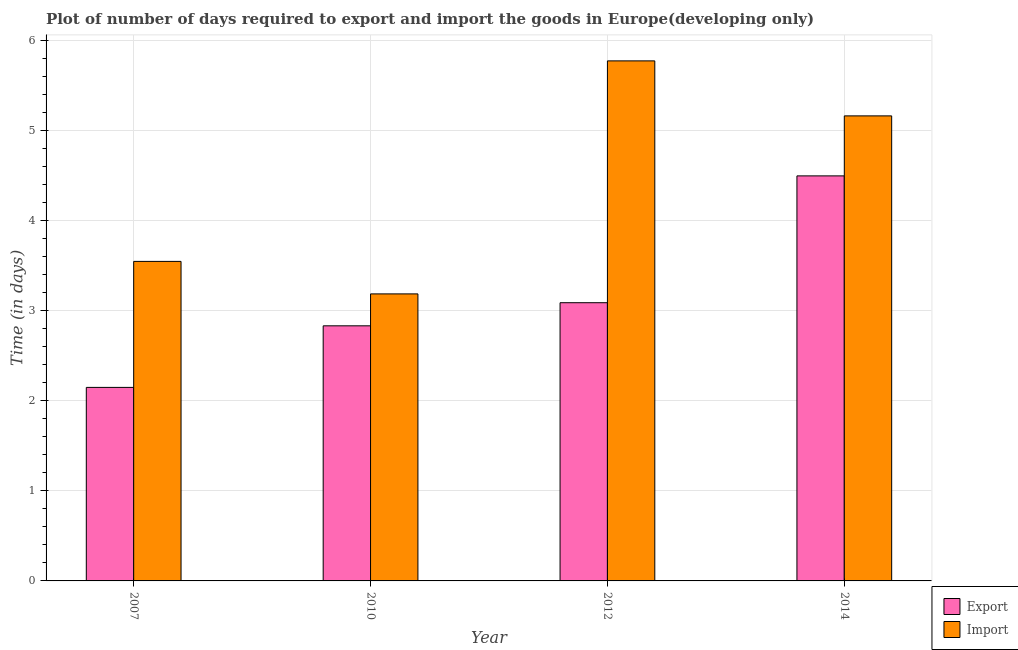How many different coloured bars are there?
Make the answer very short. 2. How many groups of bars are there?
Provide a short and direct response. 4. Are the number of bars per tick equal to the number of legend labels?
Your answer should be compact. Yes. Are the number of bars on each tick of the X-axis equal?
Provide a short and direct response. Yes. How many bars are there on the 3rd tick from the left?
Your answer should be compact. 2. What is the label of the 4th group of bars from the left?
Ensure brevity in your answer.  2014. What is the time required to export in 2014?
Keep it short and to the point. 4.5. Across all years, what is the maximum time required to import?
Keep it short and to the point. 5.78. Across all years, what is the minimum time required to import?
Offer a terse response. 3.19. In which year was the time required to import maximum?
Offer a very short reply. 2012. What is the total time required to export in the graph?
Offer a terse response. 12.58. What is the difference between the time required to import in 2012 and that in 2014?
Offer a terse response. 0.61. What is the difference between the time required to export in 2012 and the time required to import in 2007?
Give a very brief answer. 0.94. What is the average time required to import per year?
Provide a succinct answer. 4.42. In the year 2007, what is the difference between the time required to export and time required to import?
Keep it short and to the point. 0. What is the ratio of the time required to import in 2012 to that in 2014?
Offer a terse response. 1.12. Is the time required to import in 2007 less than that in 2012?
Your response must be concise. Yes. What is the difference between the highest and the second highest time required to import?
Your answer should be very brief. 0.61. What is the difference between the highest and the lowest time required to export?
Offer a terse response. 2.35. In how many years, is the time required to export greater than the average time required to export taken over all years?
Make the answer very short. 1. Is the sum of the time required to import in 2007 and 2012 greater than the maximum time required to export across all years?
Your response must be concise. Yes. What does the 1st bar from the left in 2010 represents?
Your answer should be very brief. Export. What does the 2nd bar from the right in 2010 represents?
Offer a very short reply. Export. How many bars are there?
Provide a short and direct response. 8. How many years are there in the graph?
Provide a short and direct response. 4. What is the difference between two consecutive major ticks on the Y-axis?
Provide a short and direct response. 1. Are the values on the major ticks of Y-axis written in scientific E-notation?
Ensure brevity in your answer.  No. Does the graph contain grids?
Give a very brief answer. Yes. What is the title of the graph?
Give a very brief answer. Plot of number of days required to export and import the goods in Europe(developing only). What is the label or title of the X-axis?
Make the answer very short. Year. What is the label or title of the Y-axis?
Offer a very short reply. Time (in days). What is the Time (in days) of Export in 2007?
Make the answer very short. 2.15. What is the Time (in days) of Import in 2007?
Your answer should be very brief. 3.55. What is the Time (in days) of Export in 2010?
Provide a short and direct response. 2.83. What is the Time (in days) in Import in 2010?
Make the answer very short. 3.19. What is the Time (in days) in Export in 2012?
Offer a very short reply. 3.09. What is the Time (in days) in Import in 2012?
Provide a short and direct response. 5.78. What is the Time (in days) of Import in 2014?
Provide a succinct answer. 5.17. Across all years, what is the maximum Time (in days) in Export?
Offer a very short reply. 4.5. Across all years, what is the maximum Time (in days) of Import?
Offer a terse response. 5.78. Across all years, what is the minimum Time (in days) in Export?
Offer a terse response. 2.15. Across all years, what is the minimum Time (in days) of Import?
Offer a very short reply. 3.19. What is the total Time (in days) in Export in the graph?
Provide a succinct answer. 12.58. What is the total Time (in days) of Import in the graph?
Your response must be concise. 17.68. What is the difference between the Time (in days) in Export in 2007 and that in 2010?
Ensure brevity in your answer.  -0.68. What is the difference between the Time (in days) in Import in 2007 and that in 2010?
Keep it short and to the point. 0.36. What is the difference between the Time (in days) of Export in 2007 and that in 2012?
Provide a short and direct response. -0.94. What is the difference between the Time (in days) of Import in 2007 and that in 2012?
Your response must be concise. -2.23. What is the difference between the Time (in days) of Export in 2007 and that in 2014?
Your answer should be very brief. -2.35. What is the difference between the Time (in days) of Import in 2007 and that in 2014?
Offer a very short reply. -1.62. What is the difference between the Time (in days) of Export in 2010 and that in 2012?
Ensure brevity in your answer.  -0.26. What is the difference between the Time (in days) of Import in 2010 and that in 2012?
Your answer should be very brief. -2.59. What is the difference between the Time (in days) in Export in 2010 and that in 2014?
Your response must be concise. -1.67. What is the difference between the Time (in days) in Import in 2010 and that in 2014?
Offer a very short reply. -1.98. What is the difference between the Time (in days) of Export in 2012 and that in 2014?
Offer a very short reply. -1.41. What is the difference between the Time (in days) of Import in 2012 and that in 2014?
Provide a succinct answer. 0.61. What is the difference between the Time (in days) of Export in 2007 and the Time (in days) of Import in 2010?
Your answer should be very brief. -1.04. What is the difference between the Time (in days) of Export in 2007 and the Time (in days) of Import in 2012?
Offer a very short reply. -3.63. What is the difference between the Time (in days) in Export in 2007 and the Time (in days) in Import in 2014?
Your answer should be very brief. -3.02. What is the difference between the Time (in days) in Export in 2010 and the Time (in days) in Import in 2012?
Offer a very short reply. -2.94. What is the difference between the Time (in days) of Export in 2010 and the Time (in days) of Import in 2014?
Your answer should be compact. -2.33. What is the difference between the Time (in days) in Export in 2012 and the Time (in days) in Import in 2014?
Provide a short and direct response. -2.08. What is the average Time (in days) in Export per year?
Your response must be concise. 3.14. What is the average Time (in days) of Import per year?
Your response must be concise. 4.42. In the year 2007, what is the difference between the Time (in days) in Export and Time (in days) in Import?
Your response must be concise. -1.4. In the year 2010, what is the difference between the Time (in days) in Export and Time (in days) in Import?
Give a very brief answer. -0.35. In the year 2012, what is the difference between the Time (in days) of Export and Time (in days) of Import?
Provide a succinct answer. -2.69. What is the ratio of the Time (in days) of Export in 2007 to that in 2010?
Your answer should be very brief. 0.76. What is the ratio of the Time (in days) in Import in 2007 to that in 2010?
Your answer should be very brief. 1.11. What is the ratio of the Time (in days) in Export in 2007 to that in 2012?
Provide a short and direct response. 0.7. What is the ratio of the Time (in days) in Import in 2007 to that in 2012?
Ensure brevity in your answer.  0.61. What is the ratio of the Time (in days) of Export in 2007 to that in 2014?
Your answer should be very brief. 0.48. What is the ratio of the Time (in days) of Import in 2007 to that in 2014?
Your answer should be compact. 0.69. What is the ratio of the Time (in days) in Export in 2010 to that in 2012?
Provide a short and direct response. 0.92. What is the ratio of the Time (in days) in Import in 2010 to that in 2012?
Provide a short and direct response. 0.55. What is the ratio of the Time (in days) of Export in 2010 to that in 2014?
Your answer should be very brief. 0.63. What is the ratio of the Time (in days) in Import in 2010 to that in 2014?
Make the answer very short. 0.62. What is the ratio of the Time (in days) in Export in 2012 to that in 2014?
Your answer should be compact. 0.69. What is the ratio of the Time (in days) of Import in 2012 to that in 2014?
Give a very brief answer. 1.12. What is the difference between the highest and the second highest Time (in days) of Export?
Make the answer very short. 1.41. What is the difference between the highest and the second highest Time (in days) of Import?
Offer a terse response. 0.61. What is the difference between the highest and the lowest Time (in days) in Export?
Provide a short and direct response. 2.35. What is the difference between the highest and the lowest Time (in days) of Import?
Provide a succinct answer. 2.59. 